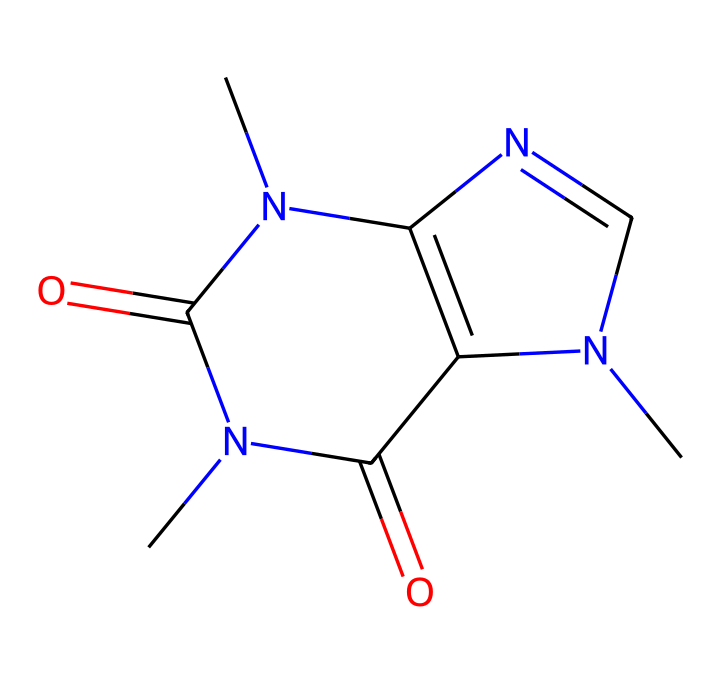What is the main component of this chemical? The SMILES representation corresponds to caffeine, which is a well-known stimulant found in energy drinks. The structure can be identified by recognizing the specific arrangement of atoms that matches the known structure of caffeine.
Answer: caffeine How many nitrogen atoms are in this caffeine structure? By examining the SMILES, we can count the number of nitrogen atoms present. The "N" symbols in the representation indicate the presence of nitrogen atoms, and in this case, there are a total of four nitrogen atoms in the structure.
Answer: four What type of chemical structure is caffeine classified as? Caffeine is classified as a purine alkaloid based on its unique arrangement of carbon, nitrogen, and oxygen, which follows characteristics seen in alkaloids. Such compounds generally have a bicyclic ring structure, and caffeine fits this classification.
Answer: purine alkaloid How many double bonds does caffeine have? The SMILES notation includes '=' symbols that indicate double bonds. Upon reviewing the structure, we identify that caffeine has a total of three double bonds.
Answer: three Does caffeine contain any oxygen atoms? Upon analyzing the SMILES representation, we can see that there are "O" symbols present, which indicate the inclusion of oxygen atoms in the structure. In this case, there are two oxygen atoms present in caffeine.
Answer: two What is the molecular formula of caffeine? The molecular formula can be derived by counting each type of atom in the structure: the SMILES indicates the count of carbon (C), hydrogen (H), nitrogen (N), and oxygen (O) atoms, leading us to recognize the complete formula as C8H10N4O2.
Answer: C8H10N4O2 